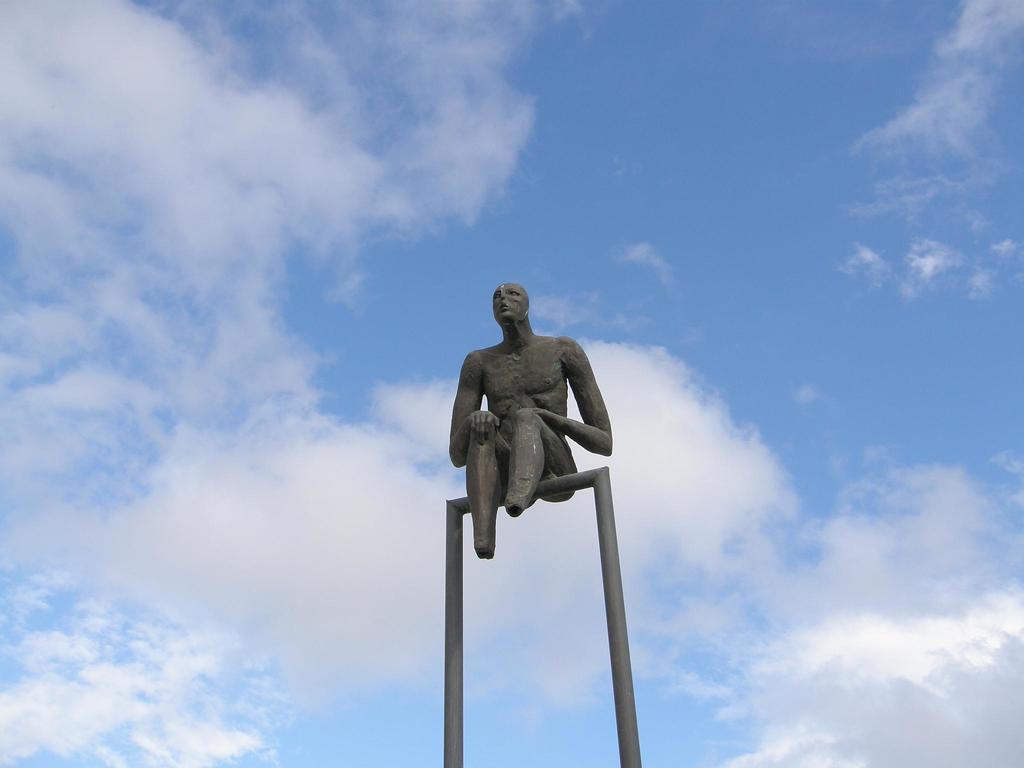Please provide a concise description of this image. In this image there is a person sculpture, there is sky,there are clouds. 